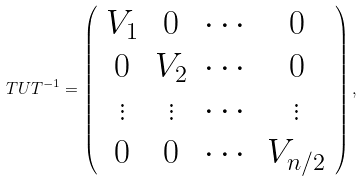<formula> <loc_0><loc_0><loc_500><loc_500>T U T ^ { - 1 } = \left ( \begin{array} { c c c c } V _ { 1 } & 0 & \cdots & 0 \\ 0 & V _ { 2 } & \cdots & 0 \\ \vdots & \vdots & \cdots & \vdots \\ 0 & 0 & \cdots & V _ { n / 2 } \\ \end{array} \right ) ,</formula> 